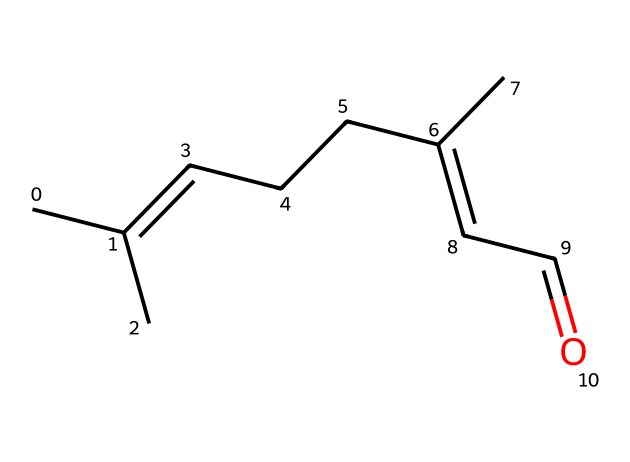how many carbon atoms are present in this molecule? By examining the SMILES representation, we can count the number of 'C' characters, which indicates carbon atoms. In this case, there are 9 carbon atoms in total.
Answer: 9 what type of compound does the provided SMILES represent? The structure depicted in the SMILES indicates that it is an aldehyde due to the presence of a carbonyl group (C=O) at the end of the carbon chain.
Answer: aldehyde how many double bonds are present in the molecular structure? The SMILES notation contains two '=' symbols, each indicating a double bond between carbon atoms, thus revealing that there are two double bonds in the molecular structure.
Answer: 2 what functional group is indicated by the ‘=O’ in the SMILES? The ‘=O’ fragment in the SMILES signifies the presence of a carbonyl group, which is characteristic of aldehydes. This group implies that the molecule has an aldehyde functional group.
Answer: carbonyl what does the presence of the chain of carbon atoms suggest about the molecule's volatility? The chain structure with multiple carbon atoms typically indicates that the molecule is relatively hydrophobic and thus volatile, which aligns with the properties of essential oils like lavender oil.
Answer: volatile 